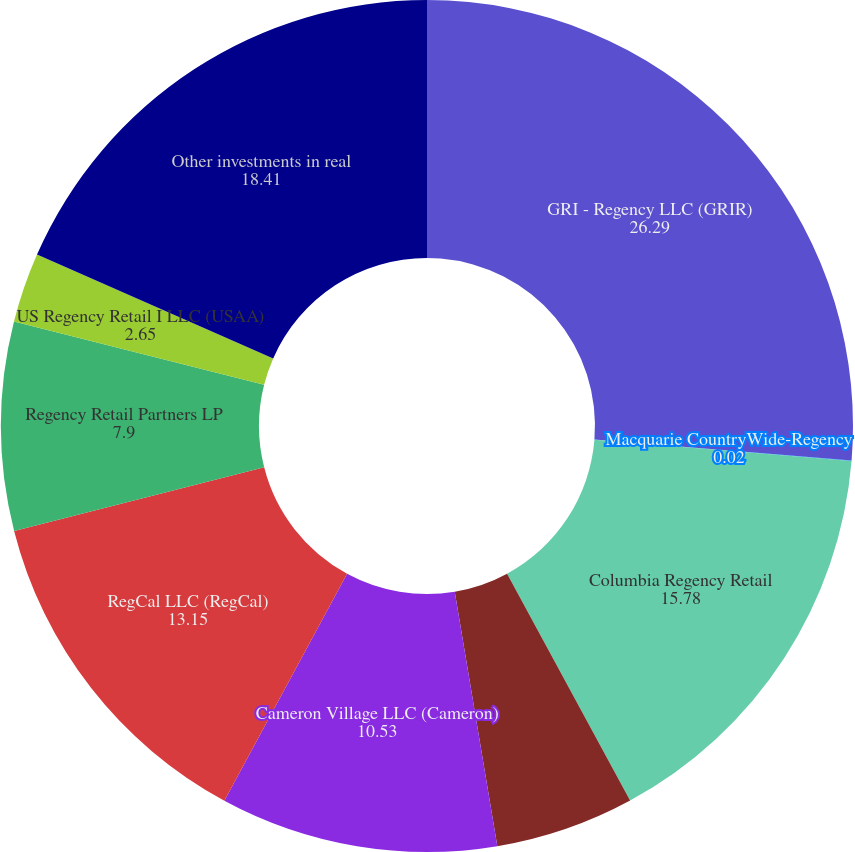Convert chart. <chart><loc_0><loc_0><loc_500><loc_500><pie_chart><fcel>GRI - Regency LLC (GRIR)<fcel>Macquarie CountryWide-Regency<fcel>Columbia Regency Retail<fcel>Columbia Regency Partners II<fcel>Cameron Village LLC (Cameron)<fcel>RegCal LLC (RegCal)<fcel>Regency Retail Partners LP<fcel>US Regency Retail I LLC (USAA)<fcel>Other investments in real<nl><fcel>26.29%<fcel>0.02%<fcel>15.78%<fcel>5.27%<fcel>10.53%<fcel>13.15%<fcel>7.9%<fcel>2.65%<fcel>18.41%<nl></chart> 